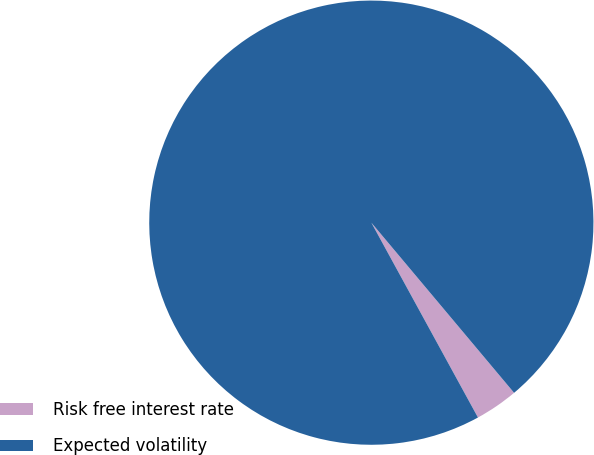Convert chart. <chart><loc_0><loc_0><loc_500><loc_500><pie_chart><fcel>Risk free interest rate<fcel>Expected volatility<nl><fcel>3.14%<fcel>96.86%<nl></chart> 